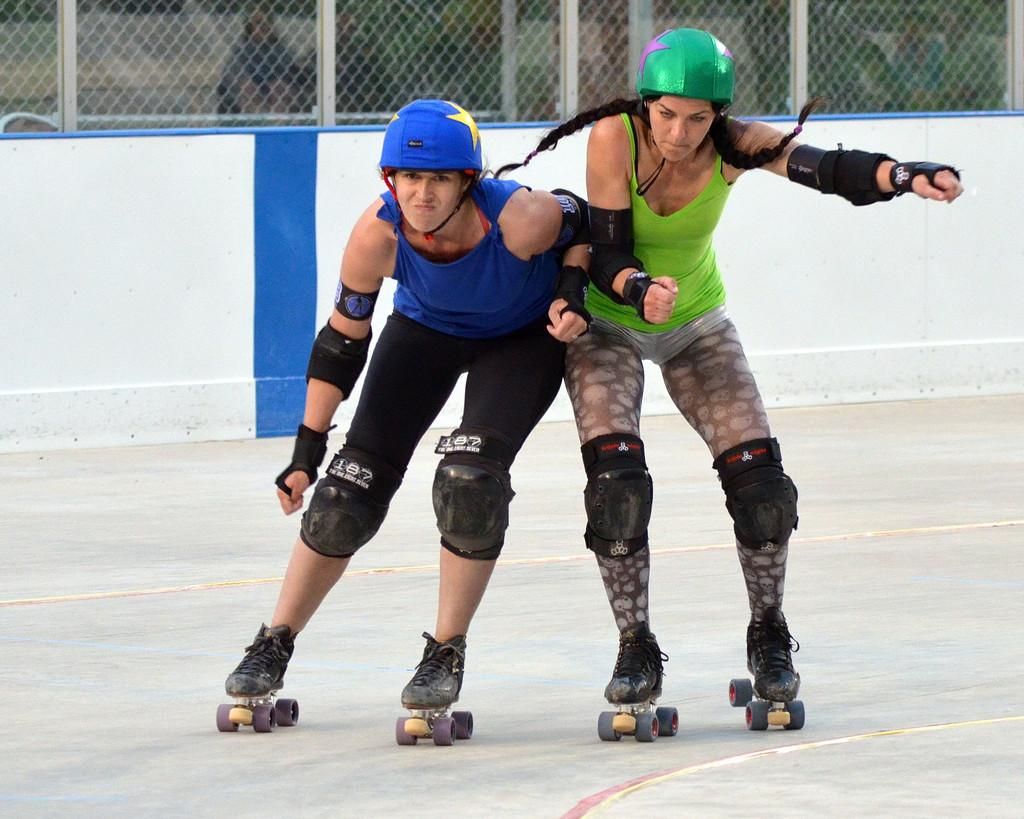How many women are in the image? There are two women in the image. What are the women doing in the image? The women are skating in the image. What safety equipment are the women wearing? The women are wearing helmets and knee pads in the image. What is at the bottom of the image? There is a floor at the bottom of the image. What can be seen in the background of the image? There is a fence and a wall in the background of the image. How many babies are visible in the image? There are no babies present in the image; it features two women skating. What year is depicted in the image? The image does not depict a specific year; it is a snapshot of the present moment. 